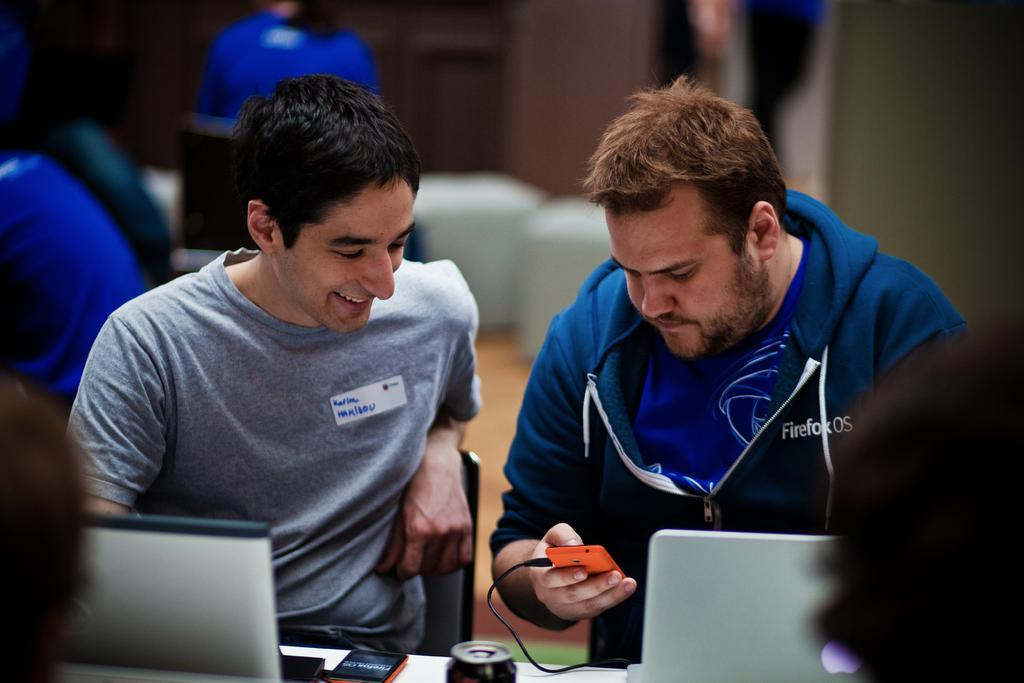How many men are sitting in the image? There are two men sitting on chairs in the image. What electronic devices can be seen in the image? There are laptops and smartphones in the image. Can you describe the people in the background of the image? There are other people in the background of the image, but their details are not clear due to the blurred background. What type of setting might the image depict? The image might depict a casual meeting or work environment, given the presence of laptops and smartphones. What type of animals can be seen in the zoo in the image? There is no zoo present in the image; it features two men sitting on chairs with laptops and smartphones. What type of food is being served on the plate in the image? There is no plate or food present in the image. 